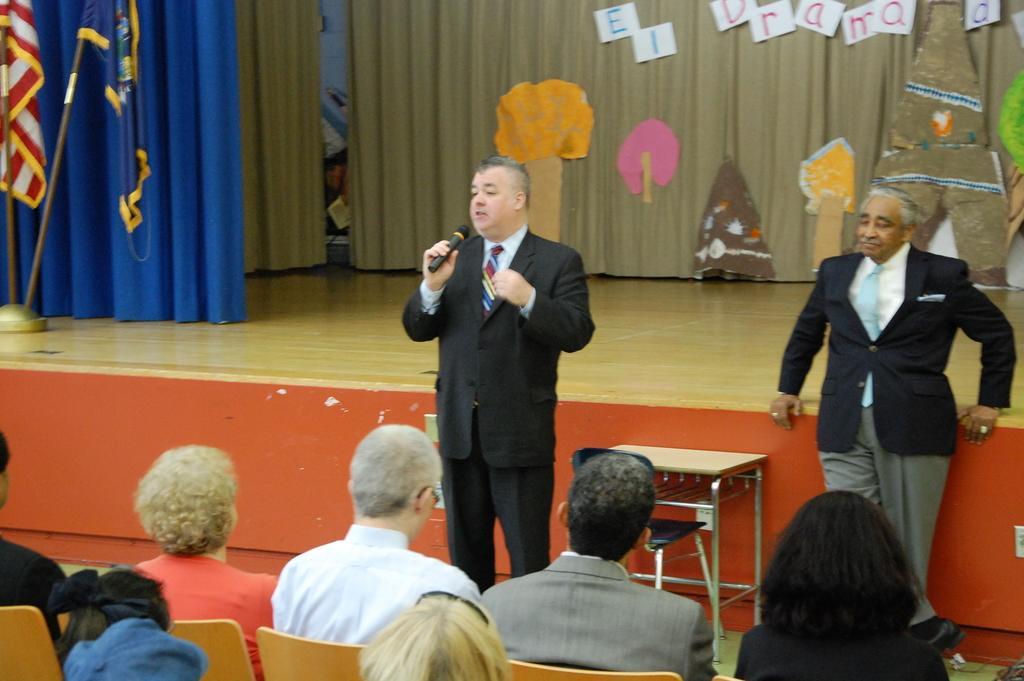Could you give a brief overview of what you see in this image? In the image we can see there are people standing and the person is holding mic in his hand and they are wearing suits. There are other people sitting on the chair. Behind there are curtains. 